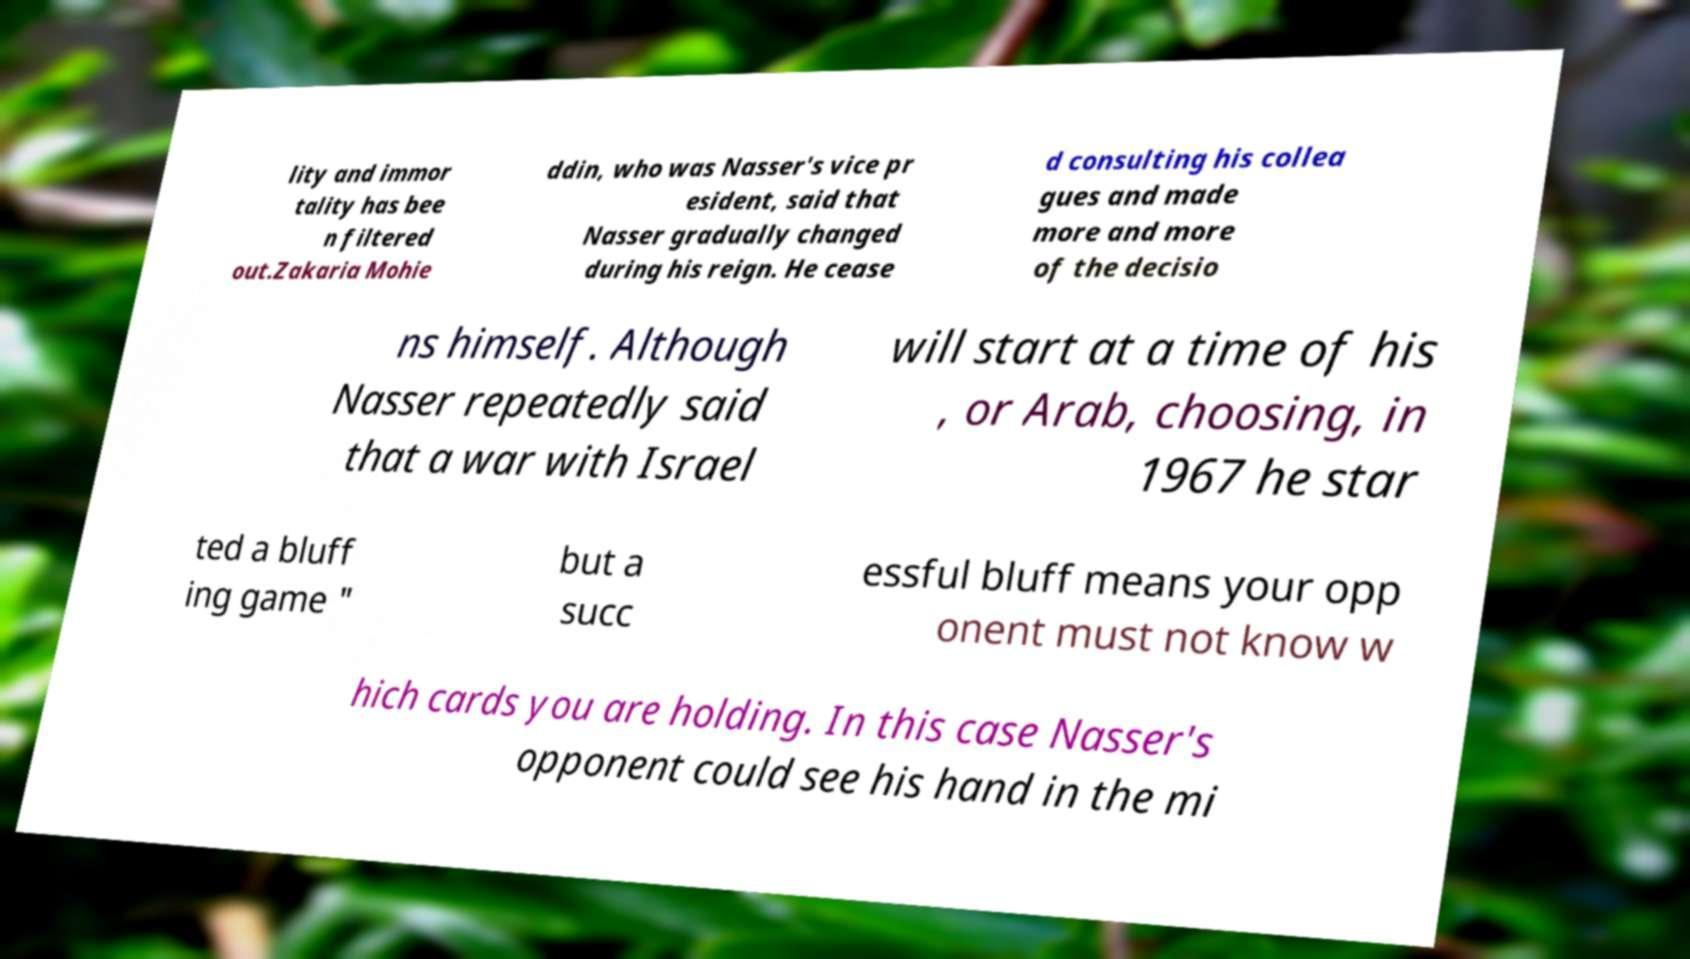Could you extract and type out the text from this image? lity and immor tality has bee n filtered out.Zakaria Mohie ddin, who was Nasser's vice pr esident, said that Nasser gradually changed during his reign. He cease d consulting his collea gues and made more and more of the decisio ns himself. Although Nasser repeatedly said that a war with Israel will start at a time of his , or Arab, choosing, in 1967 he star ted a bluff ing game " but a succ essful bluff means your opp onent must not know w hich cards you are holding. In this case Nasser's opponent could see his hand in the mi 